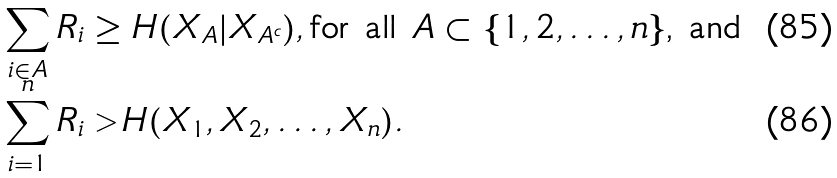Convert formula to latex. <formula><loc_0><loc_0><loc_500><loc_500>\sum _ { i \in A } R _ { i } & \geq H ( X _ { A } | X _ { A ^ { c } } ) , \text {for all $A \subset \{1, 2, \dots , n\}$, and} \\ \sum _ { i = 1 } ^ { n } R _ { i } & > H ( X _ { 1 } , X _ { 2 } , \dots , X _ { n } ) .</formula> 